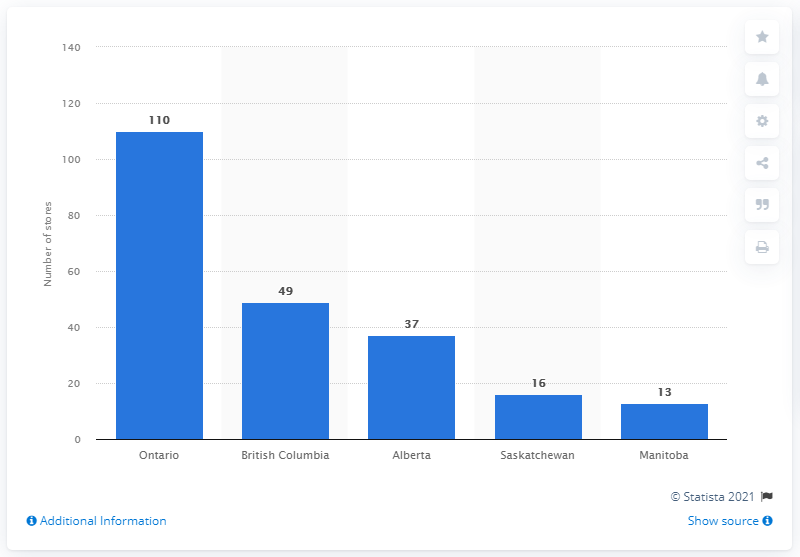Specify some key components in this picture. As of February 2019, there were 110 Dollar Tree stores located in the province of Ontario. 